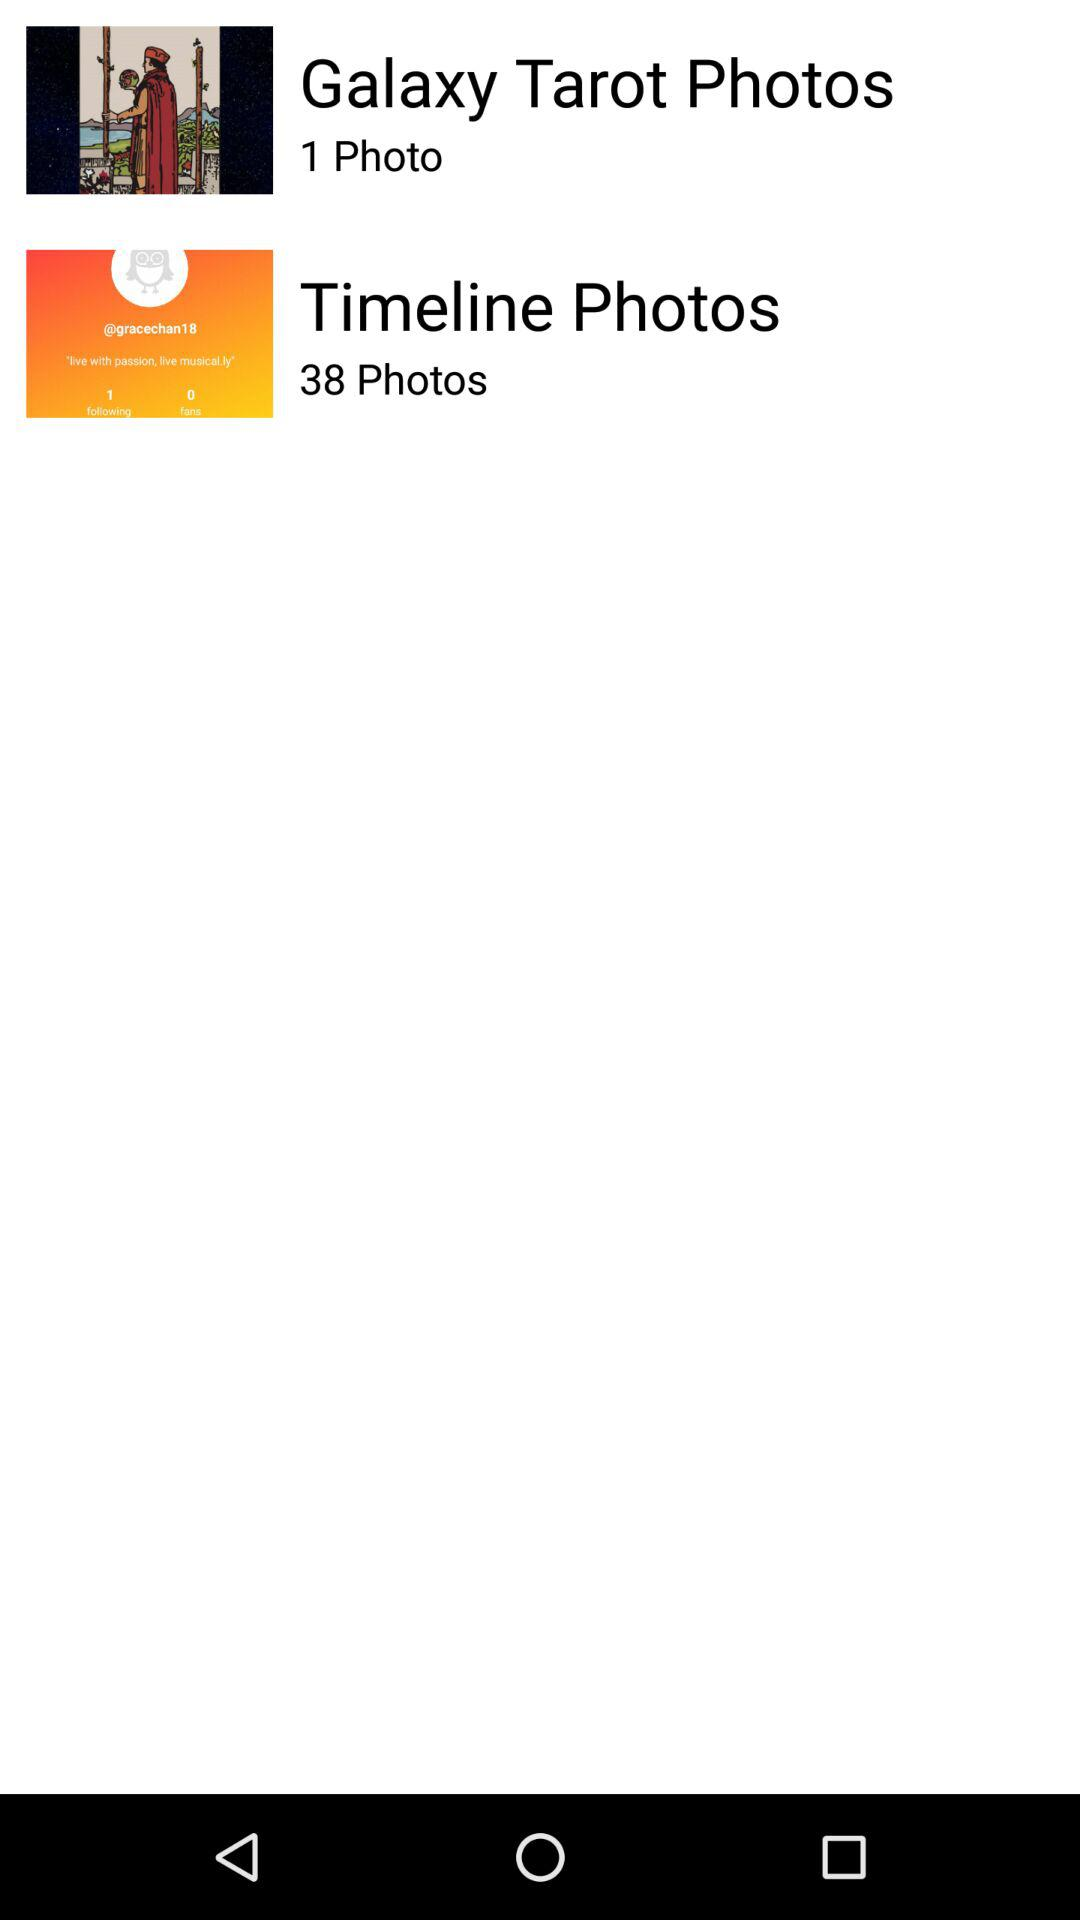Which album contains 38 photos? The album is "Timeline Photos". 